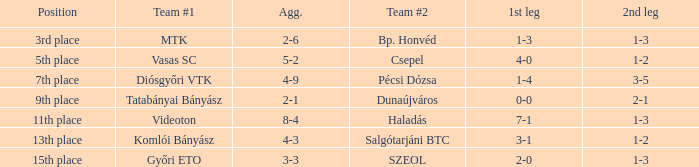What position has a 2-6 agg.? 3rd place. Would you be able to parse every entry in this table? {'header': ['Position', 'Team #1', 'Agg.', 'Team #2', '1st leg', '2nd leg'], 'rows': [['3rd place', 'MTK', '2-6', 'Bp. Honvéd', '1-3', '1-3'], ['5th place', 'Vasas SC', '5-2', 'Csepel', '4-0', '1-2'], ['7th place', 'Diósgyőri VTK', '4-9', 'Pécsi Dózsa', '1-4', '3-5'], ['9th place', 'Tatabányai Bányász', '2-1', 'Dunaújváros', '0-0', '2-1'], ['11th place', 'Videoton', '8-4', 'Haladás', '7-1', '1-3'], ['13th place', 'Komlói Bányász', '4-3', 'Salgótarjáni BTC', '3-1', '1-2'], ['15th place', 'Győri ETO', '3-3', 'SZEOL', '2-0', '1-3']]} 